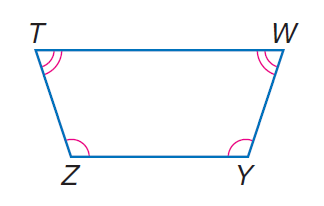Answer the mathemtical geometry problem and directly provide the correct option letter.
Question: isosceles trapezoid T W Y Z with \angle Z \cong \angle Y, m \angle Z = 30 x, \angle T \cong \angle W, and m \angle T = 20 x, find \angle W.
Choices: A: 62 B: 72 C: 108 D: 118 B 